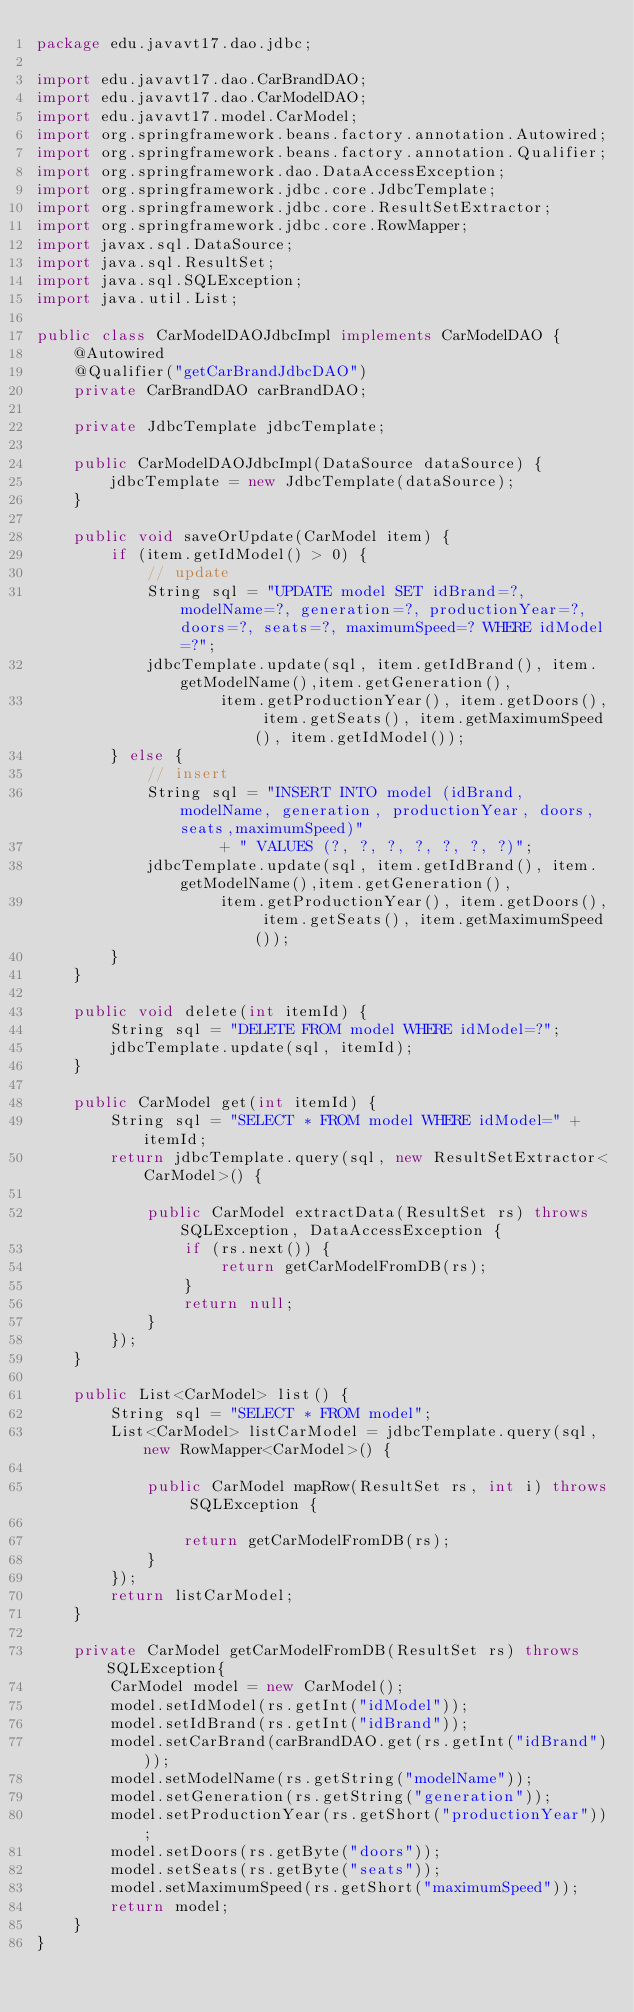Convert code to text. <code><loc_0><loc_0><loc_500><loc_500><_Java_>package edu.javavt17.dao.jdbc;

import edu.javavt17.dao.CarBrandDAO;
import edu.javavt17.dao.CarModelDAO;
import edu.javavt17.model.CarModel;
import org.springframework.beans.factory.annotation.Autowired;
import org.springframework.beans.factory.annotation.Qualifier;
import org.springframework.dao.DataAccessException;
import org.springframework.jdbc.core.JdbcTemplate;
import org.springframework.jdbc.core.ResultSetExtractor;
import org.springframework.jdbc.core.RowMapper;
import javax.sql.DataSource;
import java.sql.ResultSet;
import java.sql.SQLException;
import java.util.List;

public class CarModelDAOJdbcImpl implements CarModelDAO {
    @Autowired
    @Qualifier("getCarBrandJdbcDAO")
    private CarBrandDAO carBrandDAO;

    private JdbcTemplate jdbcTemplate;

    public CarModelDAOJdbcImpl(DataSource dataSource) {
        jdbcTemplate = new JdbcTemplate(dataSource);
    }

    public void saveOrUpdate(CarModel item) {
        if (item.getIdModel() > 0) {
            // update
            String sql = "UPDATE model SET idBrand=?, modelName=?, generation=?, productionYear=?, doors=?, seats=?, maximumSpeed=? WHERE idModel=?";
            jdbcTemplate.update(sql, item.getIdBrand(), item.getModelName(),item.getGeneration(),
                    item.getProductionYear(), item.getDoors(), item.getSeats(), item.getMaximumSpeed(), item.getIdModel());
        } else {
            // insert
            String sql = "INSERT INTO model (idBrand, modelName, generation, productionYear, doors, seats,maximumSpeed)"
                    + " VALUES (?, ?, ?, ?, ?, ?, ?)";
            jdbcTemplate.update(sql, item.getIdBrand(), item.getModelName(),item.getGeneration(),
                    item.getProductionYear(), item.getDoors(), item.getSeats(), item.getMaximumSpeed());
        }
    }

    public void delete(int itemId) {
        String sql = "DELETE FROM model WHERE idModel=?";
        jdbcTemplate.update(sql, itemId);
    }

    public CarModel get(int itemId) {
        String sql = "SELECT * FROM model WHERE idModel=" + itemId;
        return jdbcTemplate.query(sql, new ResultSetExtractor<CarModel>() {

            public CarModel extractData(ResultSet rs) throws SQLException, DataAccessException {
                if (rs.next()) {
                    return getCarModelFromDB(rs);
                }
                return null;
            }
        });
    }

    public List<CarModel> list() {
        String sql = "SELECT * FROM model";
        List<CarModel> listCarModel = jdbcTemplate.query(sql, new RowMapper<CarModel>() {

            public CarModel mapRow(ResultSet rs, int i) throws SQLException {

                return getCarModelFromDB(rs);
            }
        });
        return listCarModel;
    }

    private CarModel getCarModelFromDB(ResultSet rs) throws SQLException{
        CarModel model = new CarModel();
        model.setIdModel(rs.getInt("idModel"));
        model.setIdBrand(rs.getInt("idBrand"));
        model.setCarBrand(carBrandDAO.get(rs.getInt("idBrand")));
        model.setModelName(rs.getString("modelName"));
        model.setGeneration(rs.getString("generation"));
        model.setProductionYear(rs.getShort("productionYear"));
        model.setDoors(rs.getByte("doors"));
        model.setSeats(rs.getByte("seats"));
        model.setMaximumSpeed(rs.getShort("maximumSpeed"));
        return model;
    }
}</code> 